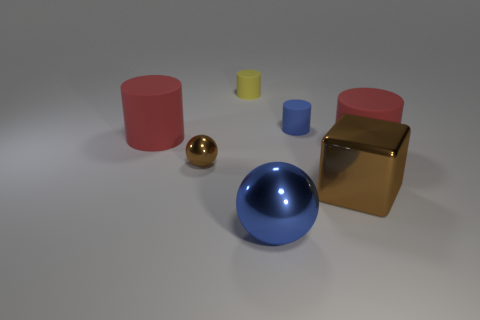Do the metal object right of the large blue sphere and the big cylinder that is on the right side of the small brown thing have the same color?
Provide a succinct answer. No. Is the number of small yellow cylinders that are right of the blue cylinder greater than the number of tiny blue matte cylinders that are left of the brown shiny cube?
Your response must be concise. No. There is a big metal object that is the same shape as the small metallic object; what is its color?
Give a very brief answer. Blue. Is there any other thing that is the same shape as the large blue thing?
Ensure brevity in your answer.  Yes. Does the tiny brown metal thing have the same shape as the blue thing that is in front of the small metal ball?
Provide a succinct answer. Yes. How many other things are there of the same material as the blue cylinder?
Keep it short and to the point. 3. Does the small metal thing have the same color as the large metal thing to the left of the large block?
Provide a short and direct response. No. There is a tiny thing left of the yellow object; what material is it?
Give a very brief answer. Metal. Is there a big cube that has the same color as the small shiny object?
Your answer should be compact. Yes. There is a metallic ball that is the same size as the cube; what color is it?
Keep it short and to the point. Blue. 